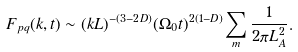<formula> <loc_0><loc_0><loc_500><loc_500>F _ { p q } ( k , t ) \sim ( k L ) ^ { - ( 3 - 2 D ) } ( \Omega _ { 0 } t ) ^ { 2 ( 1 - D ) } \sum _ { m } \frac { 1 } { 2 \pi L _ { A } ^ { 2 } } .</formula> 